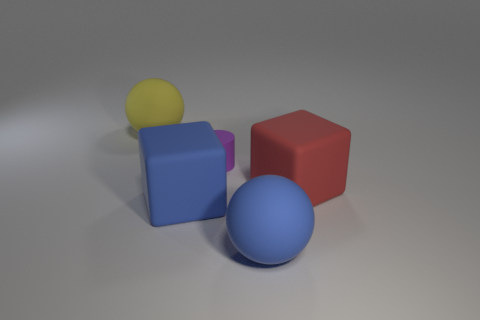There is a large blue block; are there any blue matte cubes on the right side of it?
Offer a very short reply. No. What material is the small cylinder?
Your answer should be compact. Rubber. What is the shape of the matte object that is to the right of the blue rubber sphere?
Your response must be concise. Cube. Is there a cyan rubber sphere of the same size as the yellow rubber ball?
Offer a very short reply. No. Are the large sphere that is on the right side of the blue matte block and the small purple object made of the same material?
Offer a very short reply. Yes. Are there an equal number of big blue things behind the matte cylinder and blue things that are behind the big blue matte cube?
Make the answer very short. Yes. What shape is the matte thing that is both in front of the small matte cylinder and left of the tiny purple cylinder?
Your response must be concise. Cube. How many red cubes are on the right side of the purple cylinder?
Provide a succinct answer. 1. What number of other things are there of the same shape as the big yellow object?
Your answer should be compact. 1. Are there fewer large red rubber blocks than green objects?
Make the answer very short. No. 